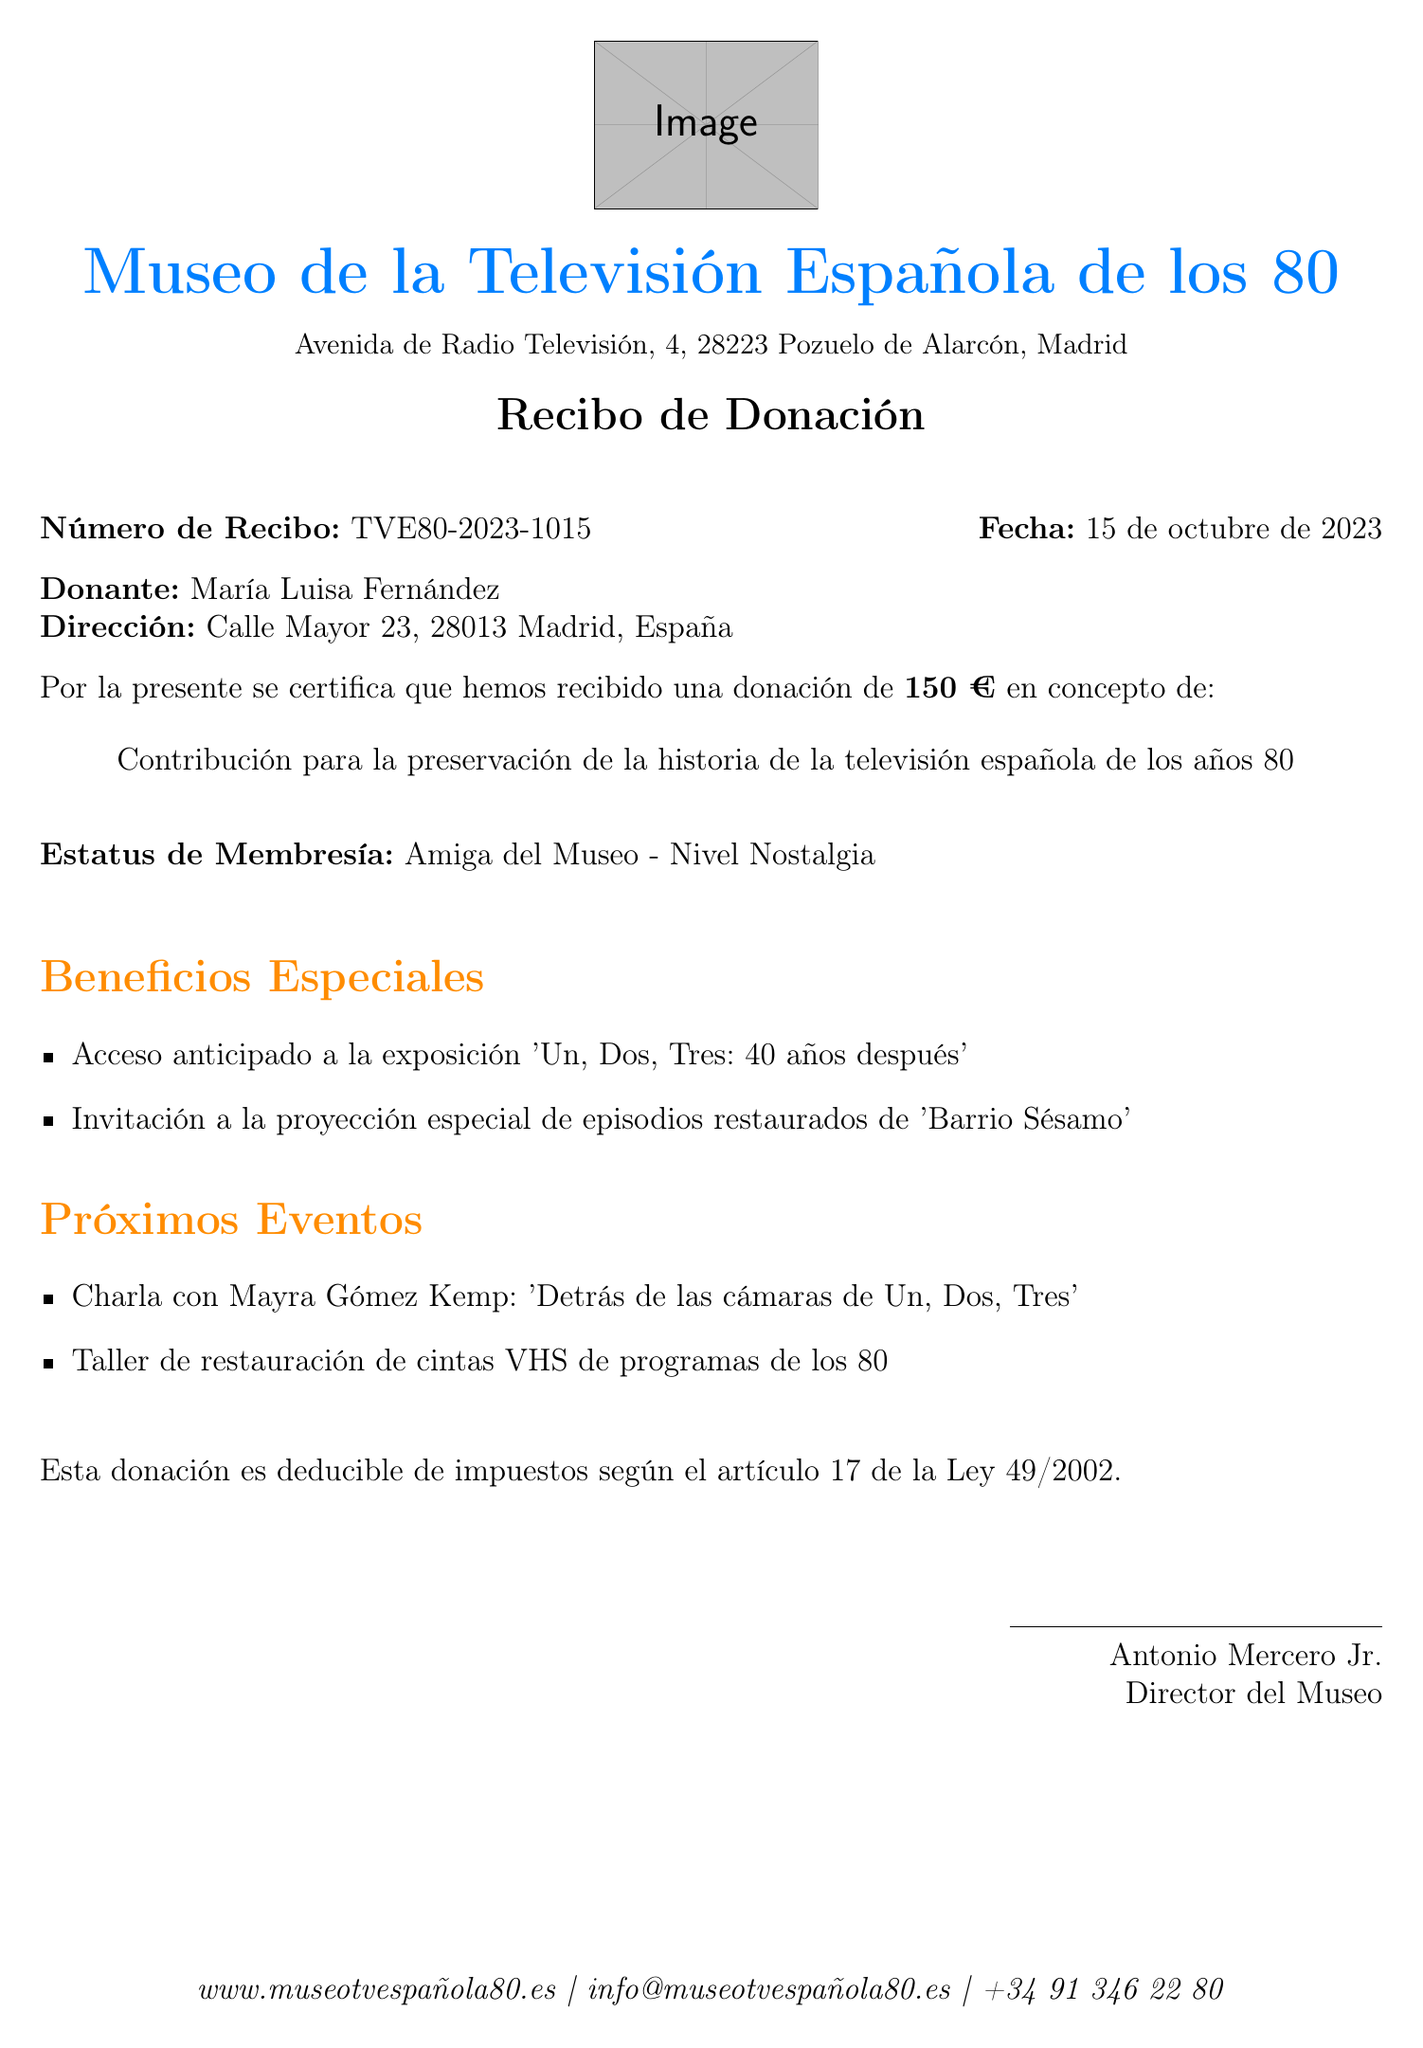¿Qué es el nombre del museo? El nombre del museo se menciona en el documento como el "Museo de la Televisión Española de los 80".
Answer: Museo de la Televisión Española de los 80 ¿Cuál es la dirección del donante? La dirección del donante es proporcionada y dice "Calle Mayor 23, 28013 Madrid, España".
Answer: Calle Mayor 23, 28013 Madrid, España ¿Cuánto fue el monto de la donación? El documento especifica que la donación fue de "150 €".
Answer: 150 € ¿Quién es el director del museo? El nombre del director del museo se incluye en el documento como "Antonio Mercero Jr.".
Answer: Antonio Mercero Jr ¿Cuáles son los beneficios especiales del donante? Los beneficios especiales incluyen acceso anticipado y una invitación a una proyección.
Answer: Acceso anticipado a la exposición 'Un, Dos, Tres: 40 años después' ¿Qué es el número del recibo? Se informa el número del recibo como "TVE80-2023-1015".
Answer: TVE80-2023-1015 ¿Cuál es la fecha de la donación? La fecha de la donación se muestra claramente en el documento como "15 de octubre de 2023".
Answer: 15 de octubre de 2023 ¿Qué artículo regula la deducción de impuestos? La información sobre la deducción de impuestos menciona "artículo 17 de la Ley 49/2002".
Answer: artículo 17 de la Ley 49/2002 ¿Cuál es un evento próximo mencionado en el documento? Se menciona un evento próximo que es una charla con Mayra Gómez Kemp.
Answer: Charla con Mayra Gómez Kemp: 'Detrás de las cámaras de Un, Dos, Tres' 